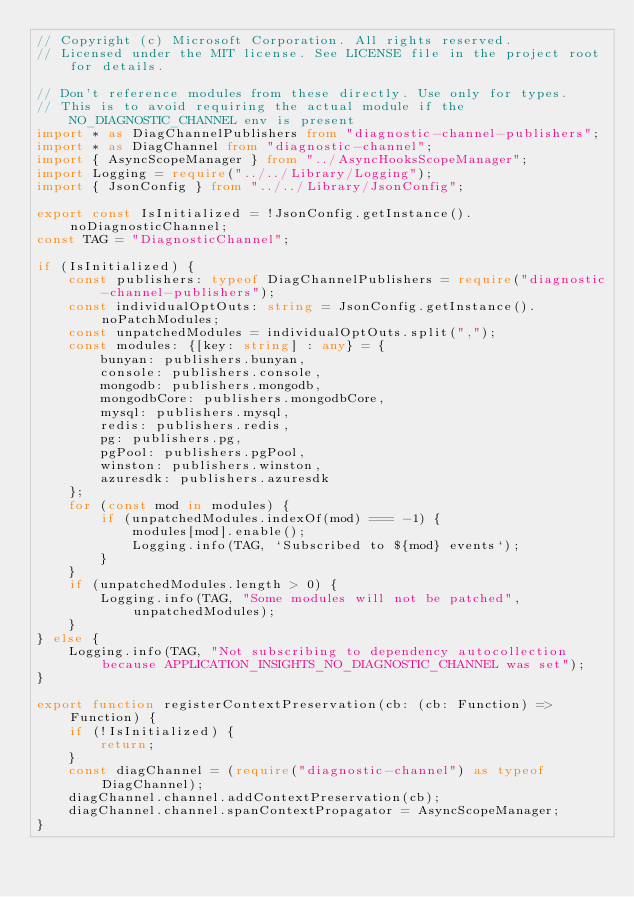Convert code to text. <code><loc_0><loc_0><loc_500><loc_500><_TypeScript_>// Copyright (c) Microsoft Corporation. All rights reserved.
// Licensed under the MIT license. See LICENSE file in the project root for details.

// Don't reference modules from these directly. Use only for types.
// This is to avoid requiring the actual module if the NO_DIAGNOSTIC_CHANNEL env is present
import * as DiagChannelPublishers from "diagnostic-channel-publishers";
import * as DiagChannel from "diagnostic-channel";
import { AsyncScopeManager } from "../AsyncHooksScopeManager";
import Logging = require("../../Library/Logging");
import { JsonConfig } from "../../Library/JsonConfig";

export const IsInitialized = !JsonConfig.getInstance().noDiagnosticChannel;
const TAG = "DiagnosticChannel";

if (IsInitialized) {
    const publishers: typeof DiagChannelPublishers = require("diagnostic-channel-publishers");
    const individualOptOuts: string = JsonConfig.getInstance().noPatchModules;
    const unpatchedModules = individualOptOuts.split(",");
    const modules: {[key: string] : any} = {
        bunyan: publishers.bunyan,
        console: publishers.console,
        mongodb: publishers.mongodb,
        mongodbCore: publishers.mongodbCore,
        mysql: publishers.mysql,
        redis: publishers.redis,
        pg: publishers.pg,
        pgPool: publishers.pgPool,
        winston: publishers.winston,
        azuresdk: publishers.azuresdk
    };
    for (const mod in modules) {
        if (unpatchedModules.indexOf(mod) === -1) {
            modules[mod].enable();
            Logging.info(TAG, `Subscribed to ${mod} events`);
        }
    }
    if (unpatchedModules.length > 0) {
        Logging.info(TAG, "Some modules will not be patched", unpatchedModules);
    }
} else {
    Logging.info(TAG, "Not subscribing to dependency autocollection because APPLICATION_INSIGHTS_NO_DIAGNOSTIC_CHANNEL was set");
}

export function registerContextPreservation(cb: (cb: Function) => Function) {
    if (!IsInitialized) {
        return;
    }
    const diagChannel = (require("diagnostic-channel") as typeof DiagChannel);
    diagChannel.channel.addContextPreservation(cb);
    diagChannel.channel.spanContextPropagator = AsyncScopeManager;
}
</code> 